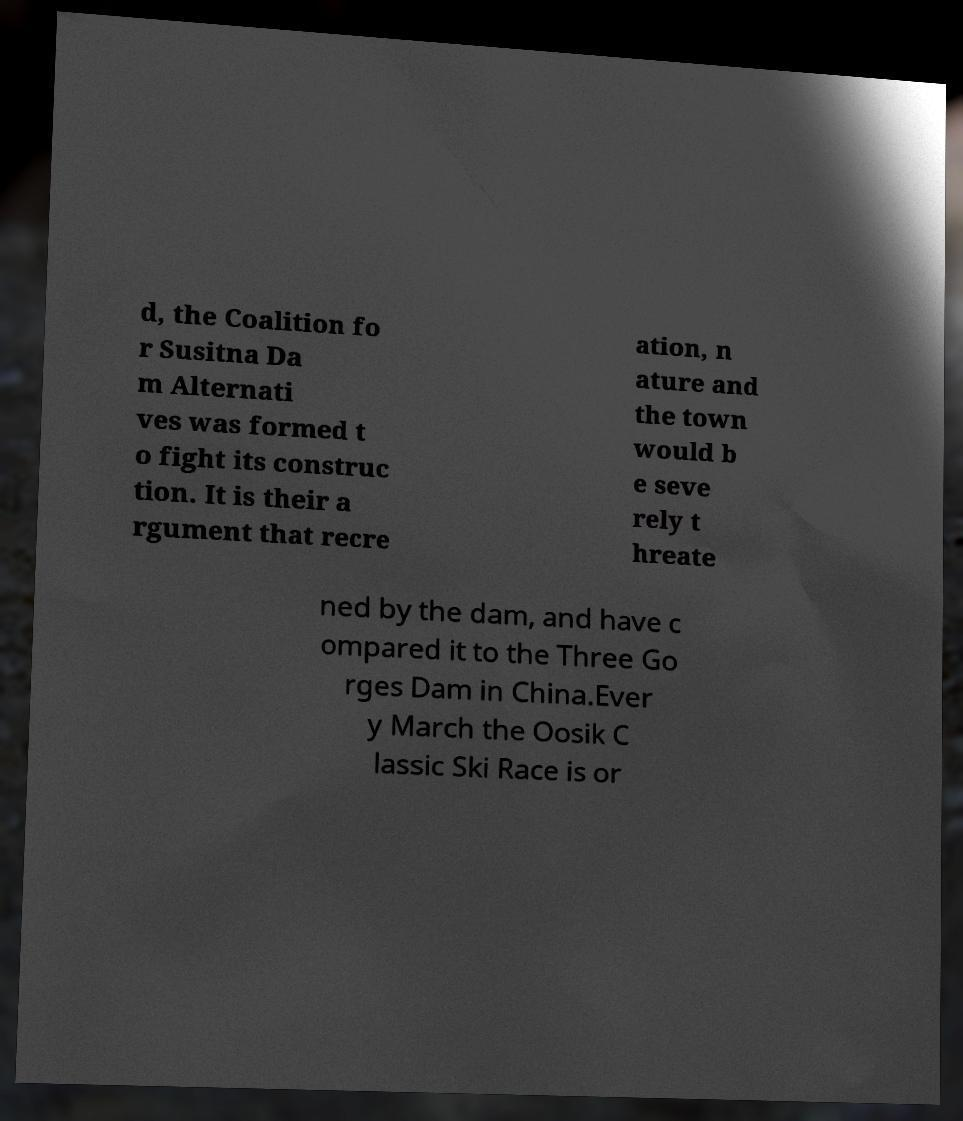There's text embedded in this image that I need extracted. Can you transcribe it verbatim? d, the Coalition fo r Susitna Da m Alternati ves was formed t o fight its construc tion. It is their a rgument that recre ation, n ature and the town would b e seve rely t hreate ned by the dam, and have c ompared it to the Three Go rges Dam in China.Ever y March the Oosik C lassic Ski Race is or 